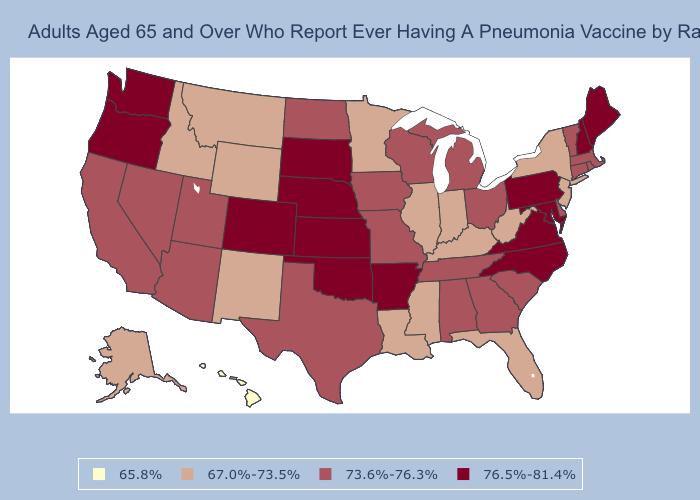What is the lowest value in states that border Nebraska?
Answer briefly. 67.0%-73.5%. Does Nebraska have a lower value than Alabama?
Give a very brief answer. No. What is the value of Kansas?
Short answer required. 76.5%-81.4%. Name the states that have a value in the range 67.0%-73.5%?
Concise answer only. Alaska, Florida, Idaho, Illinois, Indiana, Kentucky, Louisiana, Minnesota, Mississippi, Montana, New Jersey, New Mexico, New York, West Virginia, Wyoming. Which states hav the highest value in the West?
Give a very brief answer. Colorado, Oregon, Washington. Name the states that have a value in the range 65.8%?
Be succinct. Hawaii. Which states have the lowest value in the USA?
Concise answer only. Hawaii. Name the states that have a value in the range 76.5%-81.4%?
Concise answer only. Arkansas, Colorado, Kansas, Maine, Maryland, Nebraska, New Hampshire, North Carolina, Oklahoma, Oregon, Pennsylvania, South Dakota, Virginia, Washington. Does North Carolina have the highest value in the South?
Answer briefly. Yes. Name the states that have a value in the range 76.5%-81.4%?
Write a very short answer. Arkansas, Colorado, Kansas, Maine, Maryland, Nebraska, New Hampshire, North Carolina, Oklahoma, Oregon, Pennsylvania, South Dakota, Virginia, Washington. What is the lowest value in the USA?
Answer briefly. 65.8%. Does the map have missing data?
Be succinct. No. What is the value of Kansas?
Give a very brief answer. 76.5%-81.4%. Does Hawaii have the lowest value in the USA?
Give a very brief answer. Yes. Name the states that have a value in the range 65.8%?
Write a very short answer. Hawaii. 